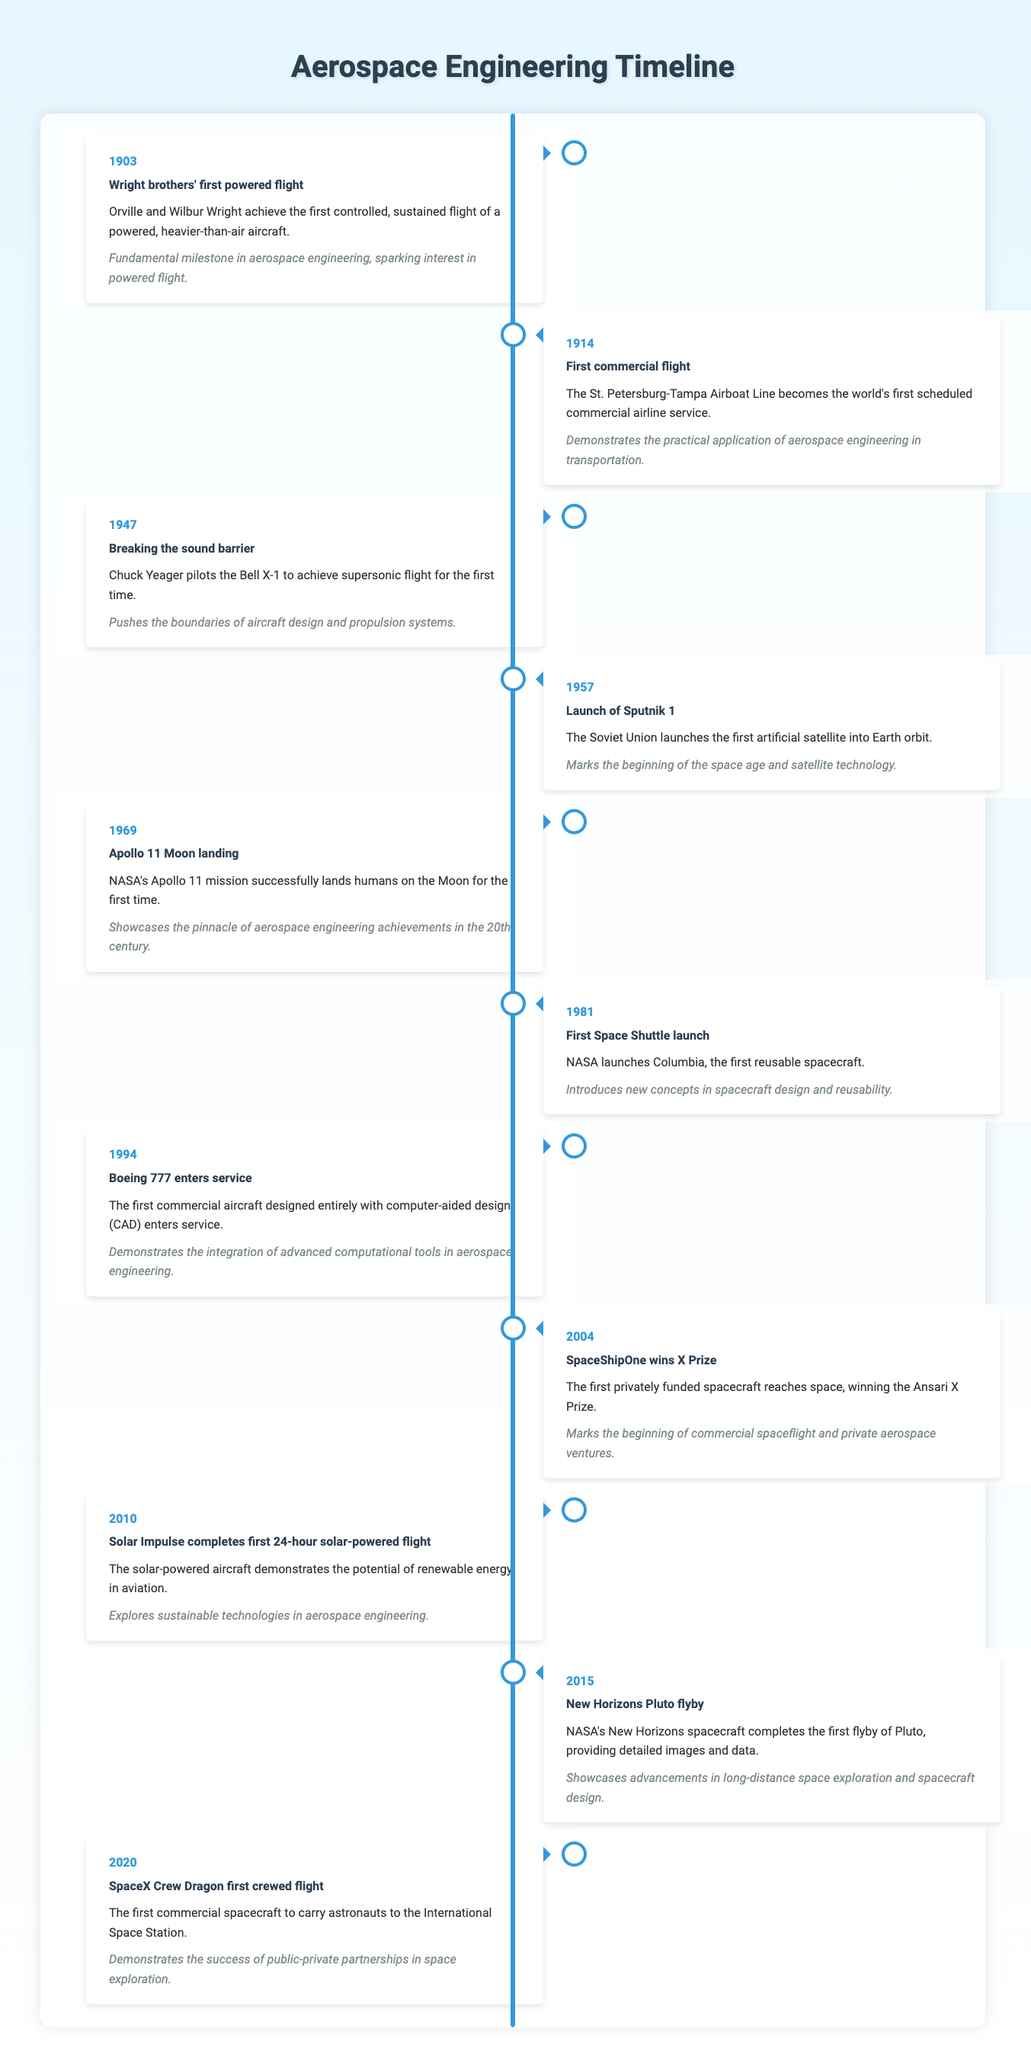What year did the Wright brothers achieve their first powered flight? According to the table, the event "Wright brothers' first powered flight" occurred in the year 1903.
Answer: 1903 How many years apart were the first commercial flight and the launch of Sputnik 1? The first commercial flight occurred in 1914 and the launch of Sputnik 1 in 1957. Subtracting 1914 from 1957 gives 43 years.
Answer: 43 years Was the Apollo 11 Moon landing the first human landing on the Moon? Yes, the description states that the Apollo 11 mission successfully landed humans on the Moon for the first time.
Answer: Yes Which event occurred in 1981 and what was its significance? The event in 1981 is the "First Space Shuttle launch," which introduced new concepts in spacecraft design and reusability, showcasing advancements in aerospace engineering.
Answer: First Space Shuttle launch; it introduced new concepts in spacecraft design and reusability What is the significance of the year 2004 in aerospace engineering? The year 2004 marks when SpaceShipOne won the X Prize, being the first privately funded spacecraft to reach space. This event signifies the beginning of commercial spaceflight and private aerospace ventures.
Answer: SpaceShipOne won the X Prize; it marked the beginning of commercial spaceflight Find the event that showcases advancements in long-distance space exploration and state what year it happened. The event that showcases advancements in long-distance space exploration is the "New Horizons Pluto flyby," which occurred in 2015 according to the timeline.
Answer: New Horizons Pluto flyby, 2015 What percentage of the listed events are related to the 21st century (2000 and later)? There are 3 events in the 21st century (2004, 2010, and 2020) and a total of 11 events. Calculating the percentage gives (3/11)*100 which is approximately 27.27 percent.
Answer: Approximately 27.27 percent Identify the two events that occurred in the 1960s and what are their relevance? The two events in the 1960s are "Apollo 11 Moon landing" (1969) and "Launch of Sputnik 1" (1957). Their relevance is that Apollo 11 showcases peak achievements in aerospace engineering, while Sputnik 1 marks the start of the space age.
Answer: Apollo 11 Moon landing and Launch of Sputnik 1; relevance: peak aerospace engineering achievements and start of the space age 